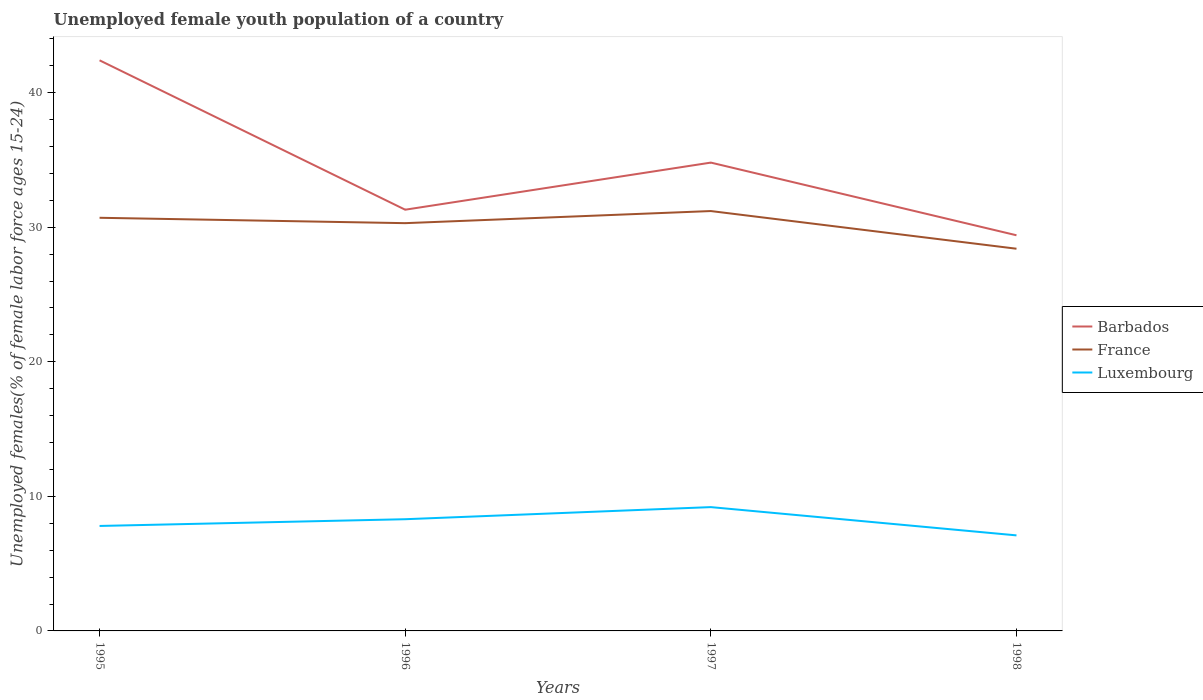Across all years, what is the maximum percentage of unemployed female youth population in France?
Ensure brevity in your answer.  28.4. What is the total percentage of unemployed female youth population in France in the graph?
Make the answer very short. 2.3. What is the difference between the highest and the second highest percentage of unemployed female youth population in France?
Offer a very short reply. 2.8. Is the percentage of unemployed female youth population in France strictly greater than the percentage of unemployed female youth population in Barbados over the years?
Ensure brevity in your answer.  Yes. Does the graph contain any zero values?
Provide a short and direct response. No. How many legend labels are there?
Ensure brevity in your answer.  3. How are the legend labels stacked?
Provide a short and direct response. Vertical. What is the title of the graph?
Your response must be concise. Unemployed female youth population of a country. Does "Seychelles" appear as one of the legend labels in the graph?
Your response must be concise. No. What is the label or title of the X-axis?
Your answer should be compact. Years. What is the label or title of the Y-axis?
Provide a succinct answer. Unemployed females(% of female labor force ages 15-24). What is the Unemployed females(% of female labor force ages 15-24) in Barbados in 1995?
Ensure brevity in your answer.  42.4. What is the Unemployed females(% of female labor force ages 15-24) in France in 1995?
Your answer should be compact. 30.7. What is the Unemployed females(% of female labor force ages 15-24) in Luxembourg in 1995?
Give a very brief answer. 7.8. What is the Unemployed females(% of female labor force ages 15-24) of Barbados in 1996?
Your answer should be very brief. 31.3. What is the Unemployed females(% of female labor force ages 15-24) of France in 1996?
Your answer should be very brief. 30.3. What is the Unemployed females(% of female labor force ages 15-24) in Luxembourg in 1996?
Offer a terse response. 8.3. What is the Unemployed females(% of female labor force ages 15-24) in Barbados in 1997?
Provide a succinct answer. 34.8. What is the Unemployed females(% of female labor force ages 15-24) in France in 1997?
Provide a short and direct response. 31.2. What is the Unemployed females(% of female labor force ages 15-24) of Luxembourg in 1997?
Offer a very short reply. 9.2. What is the Unemployed females(% of female labor force ages 15-24) of Barbados in 1998?
Provide a succinct answer. 29.4. What is the Unemployed females(% of female labor force ages 15-24) in France in 1998?
Your response must be concise. 28.4. What is the Unemployed females(% of female labor force ages 15-24) in Luxembourg in 1998?
Keep it short and to the point. 7.1. Across all years, what is the maximum Unemployed females(% of female labor force ages 15-24) of Barbados?
Keep it short and to the point. 42.4. Across all years, what is the maximum Unemployed females(% of female labor force ages 15-24) in France?
Your answer should be very brief. 31.2. Across all years, what is the maximum Unemployed females(% of female labor force ages 15-24) in Luxembourg?
Offer a very short reply. 9.2. Across all years, what is the minimum Unemployed females(% of female labor force ages 15-24) of Barbados?
Give a very brief answer. 29.4. Across all years, what is the minimum Unemployed females(% of female labor force ages 15-24) in France?
Ensure brevity in your answer.  28.4. Across all years, what is the minimum Unemployed females(% of female labor force ages 15-24) of Luxembourg?
Provide a short and direct response. 7.1. What is the total Unemployed females(% of female labor force ages 15-24) in Barbados in the graph?
Offer a terse response. 137.9. What is the total Unemployed females(% of female labor force ages 15-24) of France in the graph?
Offer a very short reply. 120.6. What is the total Unemployed females(% of female labor force ages 15-24) in Luxembourg in the graph?
Give a very brief answer. 32.4. What is the difference between the Unemployed females(% of female labor force ages 15-24) of Barbados in 1995 and that in 1996?
Ensure brevity in your answer.  11.1. What is the difference between the Unemployed females(% of female labor force ages 15-24) in France in 1995 and that in 1996?
Your answer should be compact. 0.4. What is the difference between the Unemployed females(% of female labor force ages 15-24) in Barbados in 1995 and that in 1997?
Your response must be concise. 7.6. What is the difference between the Unemployed females(% of female labor force ages 15-24) in France in 1995 and that in 1997?
Your response must be concise. -0.5. What is the difference between the Unemployed females(% of female labor force ages 15-24) in Luxembourg in 1995 and that in 1997?
Give a very brief answer. -1.4. What is the difference between the Unemployed females(% of female labor force ages 15-24) of Barbados in 1995 and that in 1998?
Your answer should be compact. 13. What is the difference between the Unemployed females(% of female labor force ages 15-24) of France in 1995 and that in 1998?
Provide a succinct answer. 2.3. What is the difference between the Unemployed females(% of female labor force ages 15-24) in Luxembourg in 1995 and that in 1998?
Provide a succinct answer. 0.7. What is the difference between the Unemployed females(% of female labor force ages 15-24) in Barbados in 1996 and that in 1997?
Make the answer very short. -3.5. What is the difference between the Unemployed females(% of female labor force ages 15-24) of Barbados in 1996 and that in 1998?
Provide a short and direct response. 1.9. What is the difference between the Unemployed females(% of female labor force ages 15-24) of France in 1996 and that in 1998?
Your answer should be very brief. 1.9. What is the difference between the Unemployed females(% of female labor force ages 15-24) of Luxembourg in 1996 and that in 1998?
Provide a short and direct response. 1.2. What is the difference between the Unemployed females(% of female labor force ages 15-24) of France in 1997 and that in 1998?
Your response must be concise. 2.8. What is the difference between the Unemployed females(% of female labor force ages 15-24) in Barbados in 1995 and the Unemployed females(% of female labor force ages 15-24) in France in 1996?
Keep it short and to the point. 12.1. What is the difference between the Unemployed females(% of female labor force ages 15-24) of Barbados in 1995 and the Unemployed females(% of female labor force ages 15-24) of Luxembourg in 1996?
Your response must be concise. 34.1. What is the difference between the Unemployed females(% of female labor force ages 15-24) of France in 1995 and the Unemployed females(% of female labor force ages 15-24) of Luxembourg in 1996?
Give a very brief answer. 22.4. What is the difference between the Unemployed females(% of female labor force ages 15-24) in Barbados in 1995 and the Unemployed females(% of female labor force ages 15-24) in Luxembourg in 1997?
Offer a terse response. 33.2. What is the difference between the Unemployed females(% of female labor force ages 15-24) of France in 1995 and the Unemployed females(% of female labor force ages 15-24) of Luxembourg in 1997?
Provide a short and direct response. 21.5. What is the difference between the Unemployed females(% of female labor force ages 15-24) in Barbados in 1995 and the Unemployed females(% of female labor force ages 15-24) in Luxembourg in 1998?
Your response must be concise. 35.3. What is the difference between the Unemployed females(% of female labor force ages 15-24) in France in 1995 and the Unemployed females(% of female labor force ages 15-24) in Luxembourg in 1998?
Give a very brief answer. 23.6. What is the difference between the Unemployed females(% of female labor force ages 15-24) in Barbados in 1996 and the Unemployed females(% of female labor force ages 15-24) in Luxembourg in 1997?
Your answer should be very brief. 22.1. What is the difference between the Unemployed females(% of female labor force ages 15-24) of France in 1996 and the Unemployed females(% of female labor force ages 15-24) of Luxembourg in 1997?
Your answer should be very brief. 21.1. What is the difference between the Unemployed females(% of female labor force ages 15-24) in Barbados in 1996 and the Unemployed females(% of female labor force ages 15-24) in France in 1998?
Offer a terse response. 2.9. What is the difference between the Unemployed females(% of female labor force ages 15-24) in Barbados in 1996 and the Unemployed females(% of female labor force ages 15-24) in Luxembourg in 1998?
Your answer should be very brief. 24.2. What is the difference between the Unemployed females(% of female labor force ages 15-24) of France in 1996 and the Unemployed females(% of female labor force ages 15-24) of Luxembourg in 1998?
Ensure brevity in your answer.  23.2. What is the difference between the Unemployed females(% of female labor force ages 15-24) of Barbados in 1997 and the Unemployed females(% of female labor force ages 15-24) of Luxembourg in 1998?
Ensure brevity in your answer.  27.7. What is the difference between the Unemployed females(% of female labor force ages 15-24) in France in 1997 and the Unemployed females(% of female labor force ages 15-24) in Luxembourg in 1998?
Offer a terse response. 24.1. What is the average Unemployed females(% of female labor force ages 15-24) of Barbados per year?
Offer a very short reply. 34.48. What is the average Unemployed females(% of female labor force ages 15-24) in France per year?
Offer a terse response. 30.15. What is the average Unemployed females(% of female labor force ages 15-24) in Luxembourg per year?
Offer a very short reply. 8.1. In the year 1995, what is the difference between the Unemployed females(% of female labor force ages 15-24) in Barbados and Unemployed females(% of female labor force ages 15-24) in France?
Offer a terse response. 11.7. In the year 1995, what is the difference between the Unemployed females(% of female labor force ages 15-24) of Barbados and Unemployed females(% of female labor force ages 15-24) of Luxembourg?
Your answer should be very brief. 34.6. In the year 1995, what is the difference between the Unemployed females(% of female labor force ages 15-24) of France and Unemployed females(% of female labor force ages 15-24) of Luxembourg?
Your answer should be very brief. 22.9. In the year 1996, what is the difference between the Unemployed females(% of female labor force ages 15-24) in Barbados and Unemployed females(% of female labor force ages 15-24) in Luxembourg?
Your answer should be very brief. 23. In the year 1997, what is the difference between the Unemployed females(% of female labor force ages 15-24) of Barbados and Unemployed females(% of female labor force ages 15-24) of France?
Keep it short and to the point. 3.6. In the year 1997, what is the difference between the Unemployed females(% of female labor force ages 15-24) in Barbados and Unemployed females(% of female labor force ages 15-24) in Luxembourg?
Provide a succinct answer. 25.6. In the year 1997, what is the difference between the Unemployed females(% of female labor force ages 15-24) of France and Unemployed females(% of female labor force ages 15-24) of Luxembourg?
Ensure brevity in your answer.  22. In the year 1998, what is the difference between the Unemployed females(% of female labor force ages 15-24) in Barbados and Unemployed females(% of female labor force ages 15-24) in Luxembourg?
Provide a short and direct response. 22.3. In the year 1998, what is the difference between the Unemployed females(% of female labor force ages 15-24) in France and Unemployed females(% of female labor force ages 15-24) in Luxembourg?
Keep it short and to the point. 21.3. What is the ratio of the Unemployed females(% of female labor force ages 15-24) in Barbados in 1995 to that in 1996?
Your answer should be very brief. 1.35. What is the ratio of the Unemployed females(% of female labor force ages 15-24) in France in 1995 to that in 1996?
Your response must be concise. 1.01. What is the ratio of the Unemployed females(% of female labor force ages 15-24) in Luxembourg in 1995 to that in 1996?
Your response must be concise. 0.94. What is the ratio of the Unemployed females(% of female labor force ages 15-24) in Barbados in 1995 to that in 1997?
Your answer should be compact. 1.22. What is the ratio of the Unemployed females(% of female labor force ages 15-24) in France in 1995 to that in 1997?
Your answer should be compact. 0.98. What is the ratio of the Unemployed females(% of female labor force ages 15-24) of Luxembourg in 1995 to that in 1997?
Ensure brevity in your answer.  0.85. What is the ratio of the Unemployed females(% of female labor force ages 15-24) in Barbados in 1995 to that in 1998?
Your response must be concise. 1.44. What is the ratio of the Unemployed females(% of female labor force ages 15-24) of France in 1995 to that in 1998?
Your answer should be very brief. 1.08. What is the ratio of the Unemployed females(% of female labor force ages 15-24) in Luxembourg in 1995 to that in 1998?
Offer a terse response. 1.1. What is the ratio of the Unemployed females(% of female labor force ages 15-24) in Barbados in 1996 to that in 1997?
Provide a short and direct response. 0.9. What is the ratio of the Unemployed females(% of female labor force ages 15-24) in France in 1996 to that in 1997?
Offer a terse response. 0.97. What is the ratio of the Unemployed females(% of female labor force ages 15-24) of Luxembourg in 1996 to that in 1997?
Offer a terse response. 0.9. What is the ratio of the Unemployed females(% of female labor force ages 15-24) in Barbados in 1996 to that in 1998?
Ensure brevity in your answer.  1.06. What is the ratio of the Unemployed females(% of female labor force ages 15-24) in France in 1996 to that in 1998?
Your response must be concise. 1.07. What is the ratio of the Unemployed females(% of female labor force ages 15-24) of Luxembourg in 1996 to that in 1998?
Ensure brevity in your answer.  1.17. What is the ratio of the Unemployed females(% of female labor force ages 15-24) of Barbados in 1997 to that in 1998?
Offer a terse response. 1.18. What is the ratio of the Unemployed females(% of female labor force ages 15-24) in France in 1997 to that in 1998?
Make the answer very short. 1.1. What is the ratio of the Unemployed females(% of female labor force ages 15-24) of Luxembourg in 1997 to that in 1998?
Offer a very short reply. 1.3. What is the difference between the highest and the second highest Unemployed females(% of female labor force ages 15-24) of Barbados?
Your response must be concise. 7.6. What is the difference between the highest and the second highest Unemployed females(% of female labor force ages 15-24) in France?
Offer a very short reply. 0.5. What is the difference between the highest and the second highest Unemployed females(% of female labor force ages 15-24) in Luxembourg?
Give a very brief answer. 0.9. What is the difference between the highest and the lowest Unemployed females(% of female labor force ages 15-24) in France?
Ensure brevity in your answer.  2.8. What is the difference between the highest and the lowest Unemployed females(% of female labor force ages 15-24) in Luxembourg?
Keep it short and to the point. 2.1. 